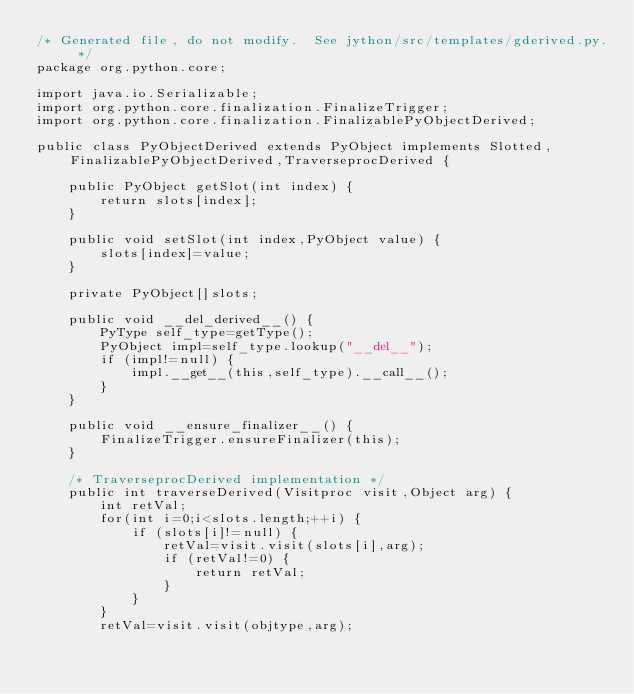<code> <loc_0><loc_0><loc_500><loc_500><_Java_>/* Generated file, do not modify.  See jython/src/templates/gderived.py. */
package org.python.core;

import java.io.Serializable;
import org.python.core.finalization.FinalizeTrigger;
import org.python.core.finalization.FinalizablePyObjectDerived;

public class PyObjectDerived extends PyObject implements Slotted,FinalizablePyObjectDerived,TraverseprocDerived {

    public PyObject getSlot(int index) {
        return slots[index];
    }

    public void setSlot(int index,PyObject value) {
        slots[index]=value;
    }

    private PyObject[]slots;

    public void __del_derived__() {
        PyType self_type=getType();
        PyObject impl=self_type.lookup("__del__");
        if (impl!=null) {
            impl.__get__(this,self_type).__call__();
        }
    }

    public void __ensure_finalizer__() {
        FinalizeTrigger.ensureFinalizer(this);
    }

    /* TraverseprocDerived implementation */
    public int traverseDerived(Visitproc visit,Object arg) {
        int retVal;
        for(int i=0;i<slots.length;++i) {
            if (slots[i]!=null) {
                retVal=visit.visit(slots[i],arg);
                if (retVal!=0) {
                    return retVal;
                }
            }
        }
        retVal=visit.visit(objtype,arg);</code> 